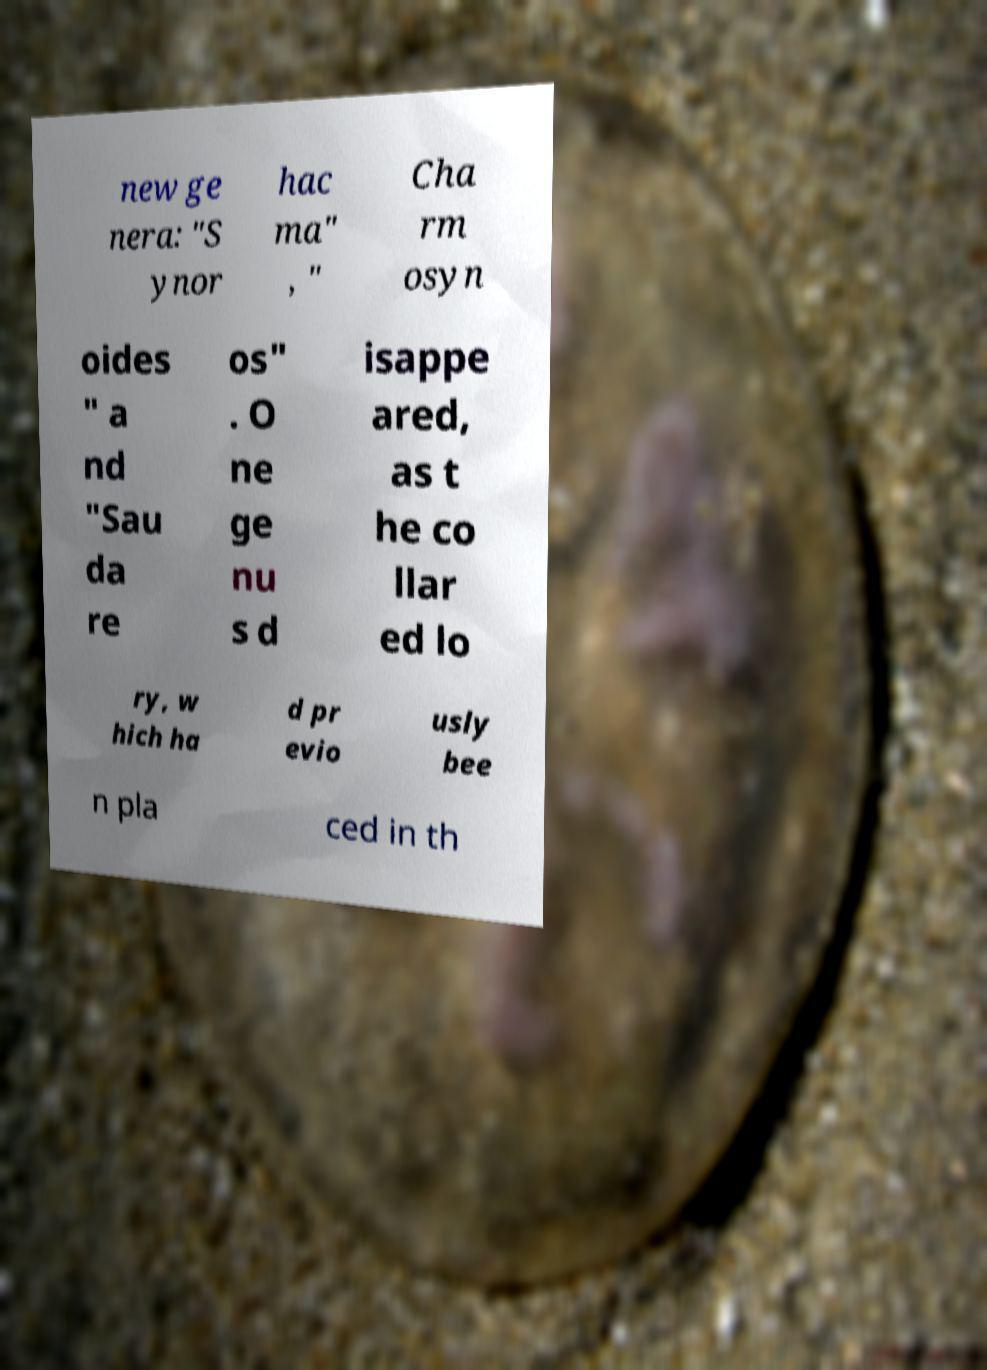Please read and relay the text visible in this image. What does it say? new ge nera: "S ynor hac ma" , " Cha rm osyn oides " a nd "Sau da re os" . O ne ge nu s d isappe ared, as t he co llar ed lo ry, w hich ha d pr evio usly bee n pla ced in th 